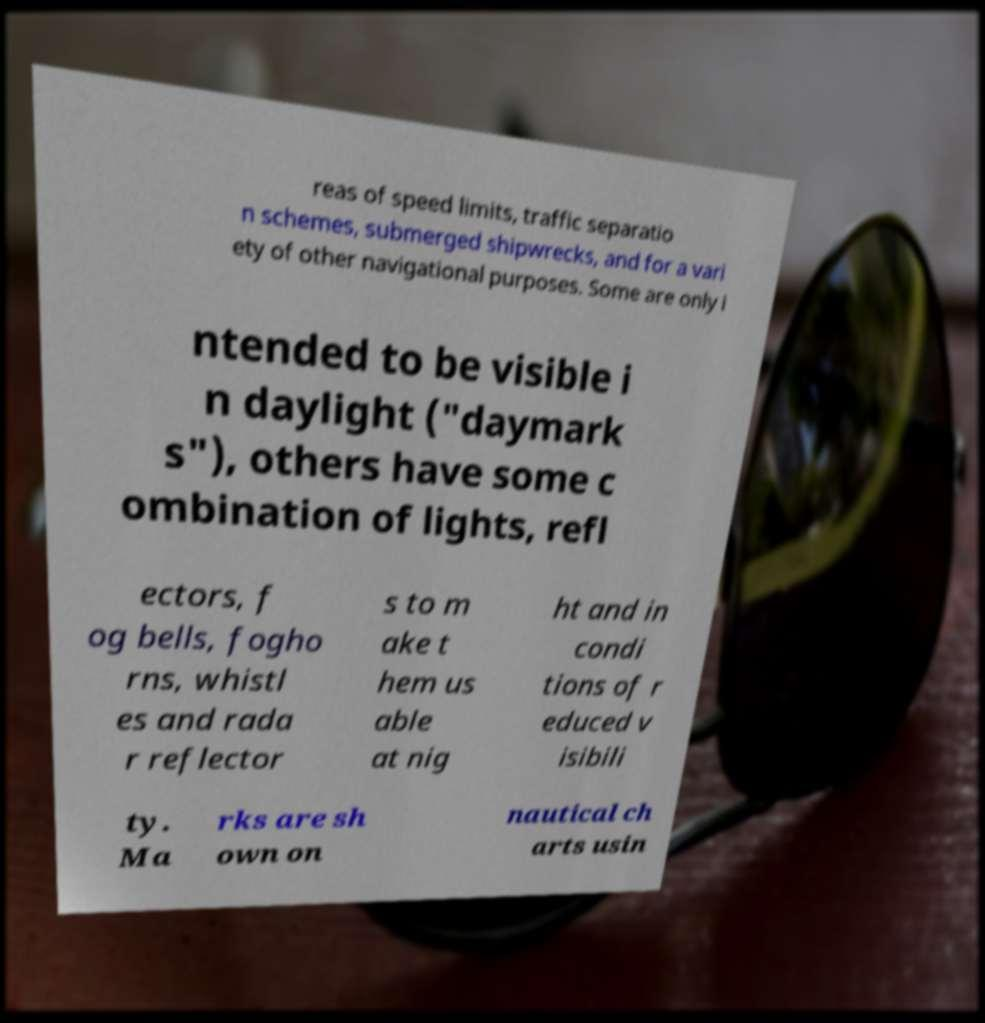There's text embedded in this image that I need extracted. Can you transcribe it verbatim? reas of speed limits, traffic separatio n schemes, submerged shipwrecks, and for a vari ety of other navigational purposes. Some are only i ntended to be visible i n daylight ("daymark s"), others have some c ombination of lights, refl ectors, f og bells, fogho rns, whistl es and rada r reflector s to m ake t hem us able at nig ht and in condi tions of r educed v isibili ty. Ma rks are sh own on nautical ch arts usin 